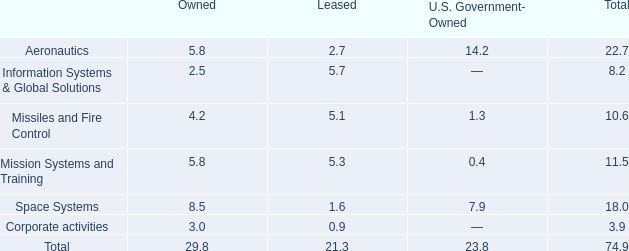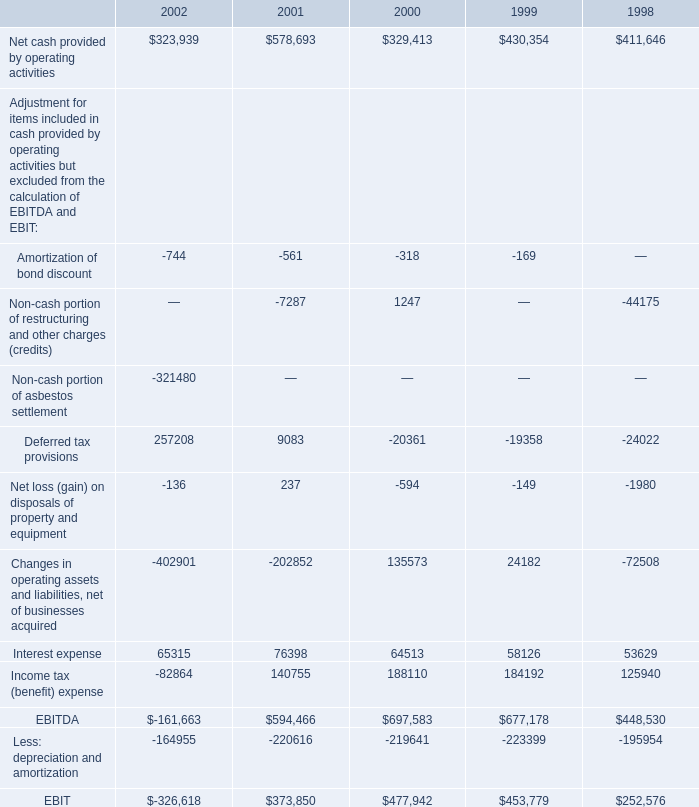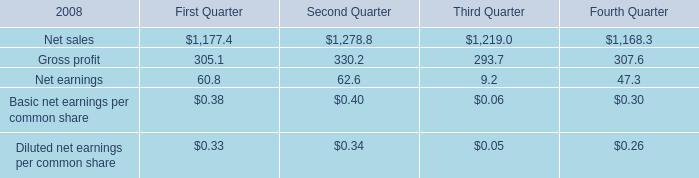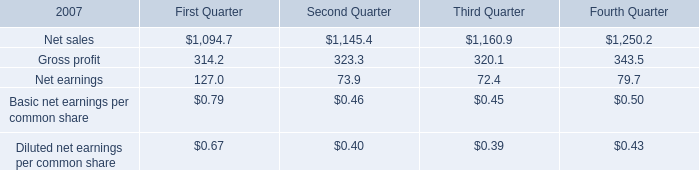what's the total amount of Net cash provided by operating activities of 2001, Net sales of Fourth Quarter, and Net cash provided by operating activities of 1999 ? 
Computations: ((578693.0 + 1168.3) + 430354.0)
Answer: 1010215.3. 